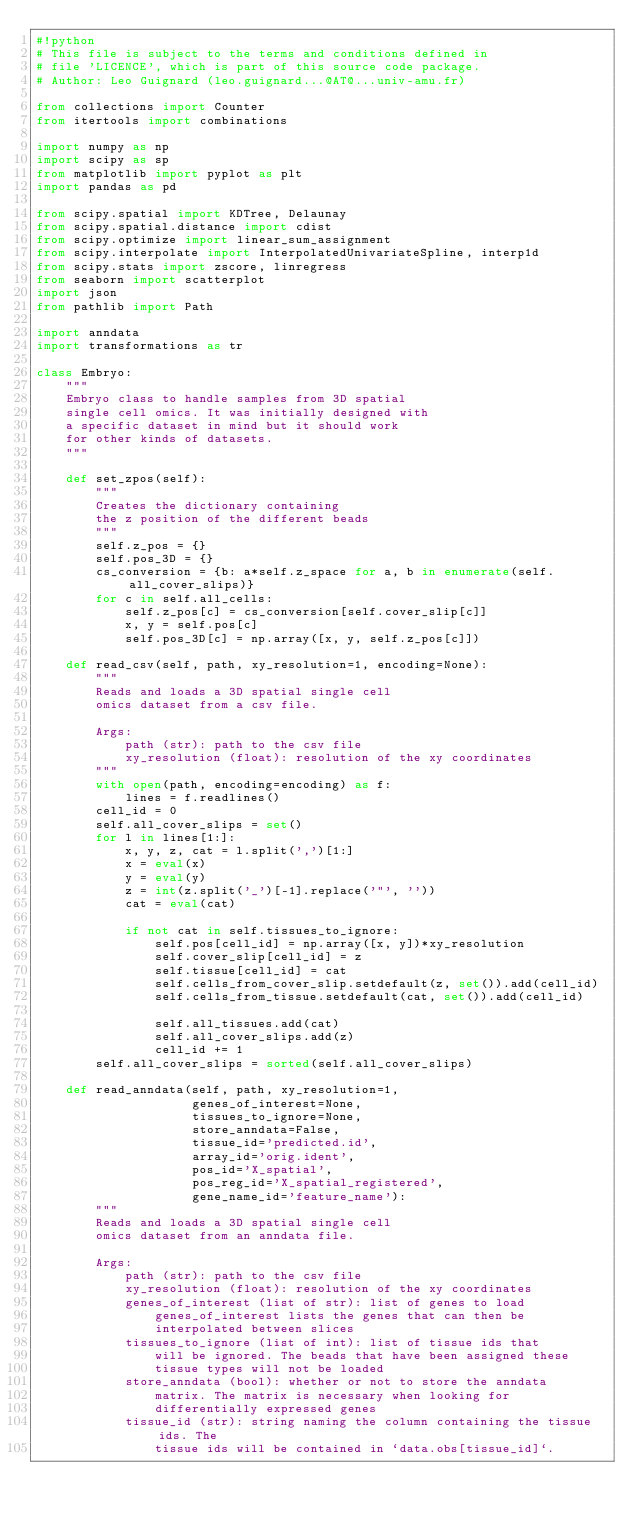Convert code to text. <code><loc_0><loc_0><loc_500><loc_500><_Python_>#!python
# This file is subject to the terms and conditions defined in
# file 'LICENCE', which is part of this source code package.
# Author: Leo Guignard (leo.guignard...@AT@...univ-amu.fr)

from collections import Counter
from itertools import combinations

import numpy as np
import scipy as sp
from matplotlib import pyplot as plt
import pandas as pd

from scipy.spatial import KDTree, Delaunay
from scipy.spatial.distance import cdist
from scipy.optimize import linear_sum_assignment
from scipy.interpolate import InterpolatedUnivariateSpline, interp1d
from scipy.stats import zscore, linregress
from seaborn import scatterplot
import json
from pathlib import Path

import anndata
import transformations as tr

class Embryo:
    """
    Embryo class to handle samples from 3D spatial
    single cell omics. It was initially designed with
    a specific dataset in mind but it should work
    for other kinds of datasets.
    """

    def set_zpos(self):
        """
        Creates the dictionary containing
        the z position of the different beads
        """
        self.z_pos = {}
        self.pos_3D = {}
        cs_conversion = {b: a*self.z_space for a, b in enumerate(self.all_cover_slips)}
        for c in self.all_cells:
            self.z_pos[c] = cs_conversion[self.cover_slip[c]]
            x, y = self.pos[c]
            self.pos_3D[c] = np.array([x, y, self.z_pos[c]])

    def read_csv(self, path, xy_resolution=1, encoding=None):
        """
        Reads and loads a 3D spatial single cell
        omics dataset from a csv file.

        Args:
            path (str): path to the csv file
            xy_resolution (float): resolution of the xy coordinates
        """
        with open(path, encoding=encoding) as f:
            lines = f.readlines()
        cell_id = 0
        self.all_cover_slips = set()
        for l in lines[1:]:
            x, y, z, cat = l.split(',')[1:]
            x = eval(x)
            y = eval(y)
            z = int(z.split('_')[-1].replace('"', ''))
            cat = eval(cat)

            if not cat in self.tissues_to_ignore:
                self.pos[cell_id] = np.array([x, y])*xy_resolution
                self.cover_slip[cell_id] = z
                self.tissue[cell_id] = cat
                self.cells_from_cover_slip.setdefault(z, set()).add(cell_id)
                self.cells_from_tissue.setdefault(cat, set()).add(cell_id)

                self.all_tissues.add(cat)
                self.all_cover_slips.add(z)
                cell_id += 1
        self.all_cover_slips = sorted(self.all_cover_slips)

    def read_anndata(self, path, xy_resolution=1,
                     genes_of_interest=None,
                     tissues_to_ignore=None,
                     store_anndata=False,
                     tissue_id='predicted.id',
                     array_id='orig.ident',
                     pos_id='X_spatial',
                     pos_reg_id='X_spatial_registered',
                     gene_name_id='feature_name'):
        """
        Reads and loads a 3D spatial single cell
        omics dataset from an anndata file.

        Args:
            path (str): path to the csv file
            xy_resolution (float): resolution of the xy coordinates
            genes_of_interest (list of str): list of genes to load
                genes_of_interest lists the genes that can then be
                interpolated between slices
            tissues_to_ignore (list of int): list of tissue ids that
                will be ignored. The beads that have been assigned these
                tissue types will not be loaded
            store_anndata (bool): whether or not to store the anndata
                matrix. The matrix is necessary when looking for
                differentially expressed genes
            tissue_id (str): string naming the column containing the tissue ids. The
                tissue ids will be contained in `data.obs[tissue_id]`.</code> 